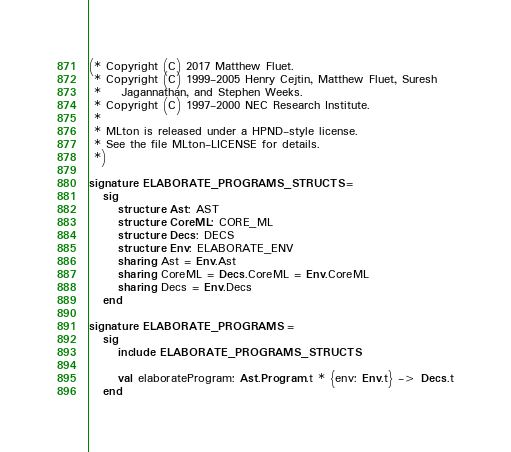<code> <loc_0><loc_0><loc_500><loc_500><_SML_>(* Copyright (C) 2017 Matthew Fluet.
 * Copyright (C) 1999-2005 Henry Cejtin, Matthew Fluet, Suresh
 *    Jagannathan, and Stephen Weeks.
 * Copyright (C) 1997-2000 NEC Research Institute.
 *
 * MLton is released under a HPND-style license.
 * See the file MLton-LICENSE for details.
 *)

signature ELABORATE_PROGRAMS_STRUCTS = 
   sig
      structure Ast: AST
      structure CoreML: CORE_ML
      structure Decs: DECS
      structure Env: ELABORATE_ENV
      sharing Ast = Env.Ast
      sharing CoreML = Decs.CoreML = Env.CoreML
      sharing Decs = Env.Decs
   end

signature ELABORATE_PROGRAMS = 
   sig
      include ELABORATE_PROGRAMS_STRUCTS

      val elaborateProgram: Ast.Program.t * {env: Env.t} -> Decs.t
   end
</code> 